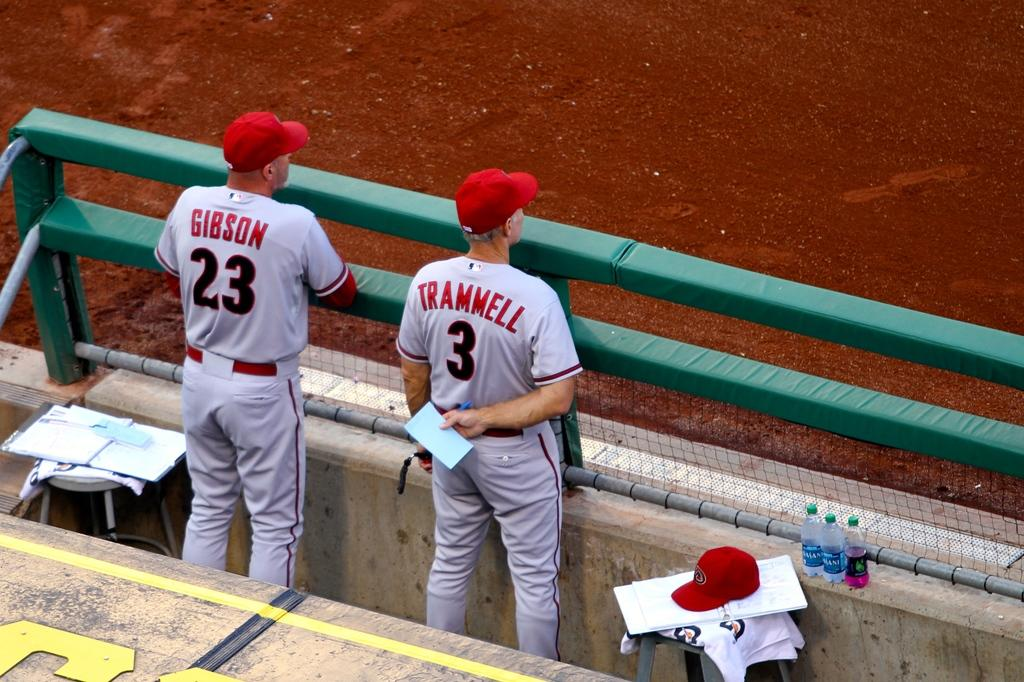<image>
Give a short and clear explanation of the subsequent image. Trammell, player 3, holds a blue piece of paper behind his back. 